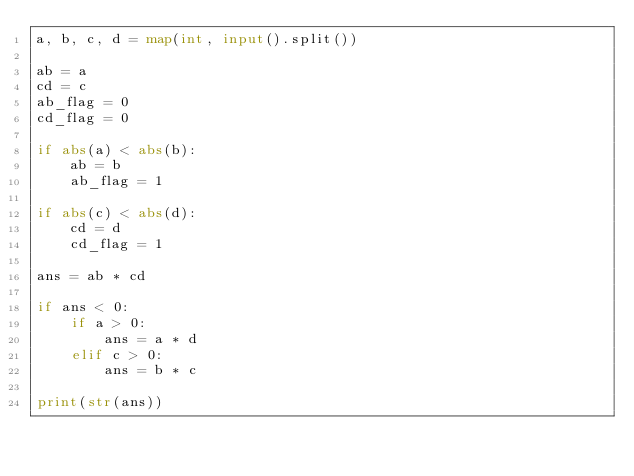Convert code to text. <code><loc_0><loc_0><loc_500><loc_500><_Python_>a, b, c, d = map(int, input().split())

ab = a
cd = c
ab_flag = 0
cd_flag = 0

if abs(a) < abs(b):
    ab = b
    ab_flag = 1

if abs(c) < abs(d):
    cd = d
    cd_flag = 1

ans = ab * cd

if ans < 0:
    if a > 0:
        ans = a * d
    elif c > 0:
        ans = b * c

print(str(ans))</code> 